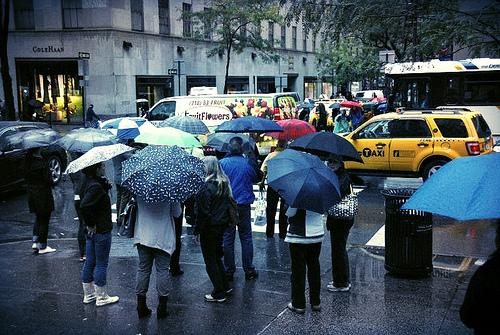Identify the color and pattern of the umbrella held by the woman. The woman's umbrella is solid blue in color. Mention the type of shoes the girl is wearing and their color. The girl is wearing white tennis shoes. What is the state of the sidewalk in the image? The sidewalk is wet. Describe the vehicle with the flowers logo and its purpose. There is a white van with a flowers logo, suggesting it's used for flower delivery. Mention the type of bus present in the background. There is a large white commuter bus with yellow and blue stripes at a bus stop. Describe the appearance of the store front in the image. There is a Cole Haan store front with a black sign on the wall. Describe the taxi vehicle present in the scene. There is a yellow taxi in the form of an SUV in the street. What type of umbrella can be seen in the back of a pack? There is a printed umbrella in the back of a pack. What type of footwear is the woman wearing and what color are they? The woman is wearing white boots. Name an object found on the sidewalk and describe its appearance. There is a black metal trash can on the sidewalk. 